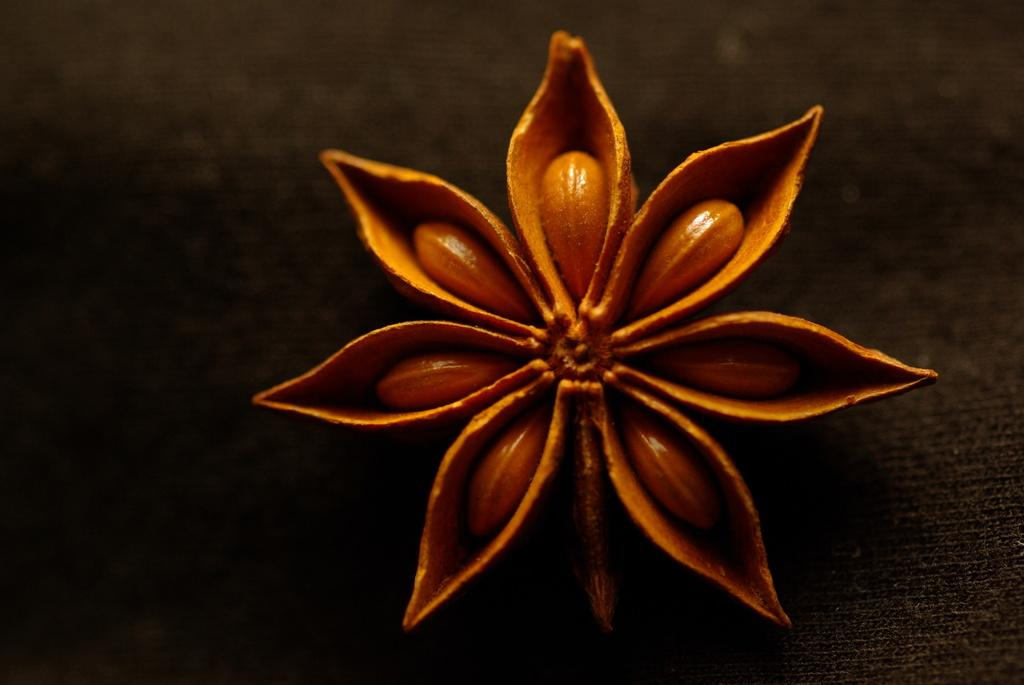What is depicted in the image? There is a symbol of anise in the image. Is there a ring visible in the image? There is no ring present in the image; it only features a symbol of anise. Can you see a line in the image? The image does not show a line; it only features a symbol of anise. Is there a rat in the image? There is no rat present in the image; it only features a symbol of anise. 